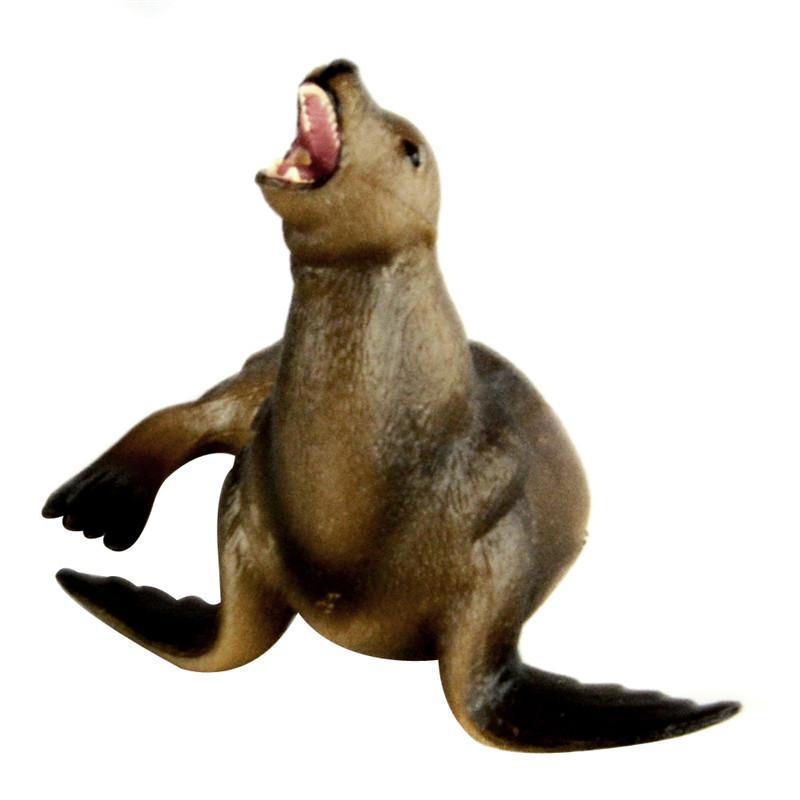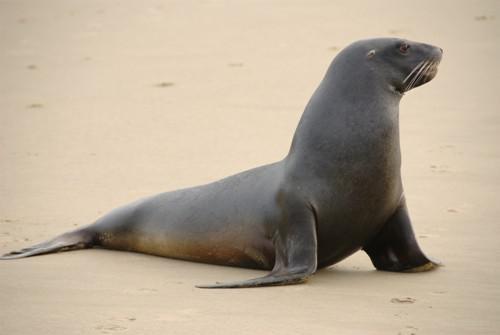The first image is the image on the left, the second image is the image on the right. For the images displayed, is the sentence "1 seal is pointed toward the right outside." factually correct? Answer yes or no. Yes. 